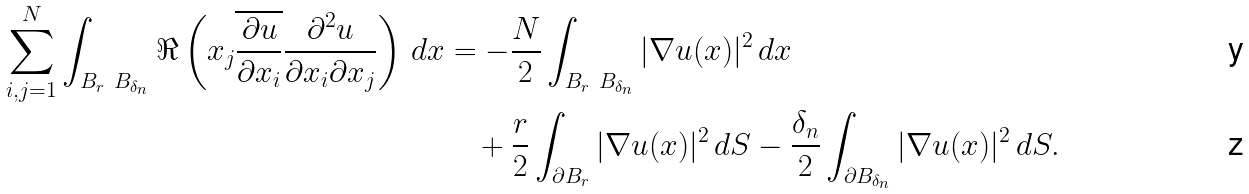<formula> <loc_0><loc_0><loc_500><loc_500>\sum _ { i , j = 1 } ^ { N } \int _ { B _ { r } \ B _ { \delta _ { n } } } \Re \left ( x _ { j } \overline { \frac { \partial u } { \partial x _ { i } } } \frac { \partial ^ { 2 } u } { \partial x _ { i } \partial x _ { j } } \right ) \, d x & = - \frac { N } { 2 } \int _ { B _ { r } \ B _ { \delta _ { n } } } | \nabla u ( x ) | ^ { 2 } \, d x \\ & \quad + \frac { r } { 2 } \int _ { \partial B _ { r } } | \nabla u ( x ) | ^ { 2 } \, d S - \frac { \delta _ { n } } 2 \int _ { \partial B _ { \delta _ { n } } } | \nabla u ( x ) | ^ { 2 } \, d S .</formula> 